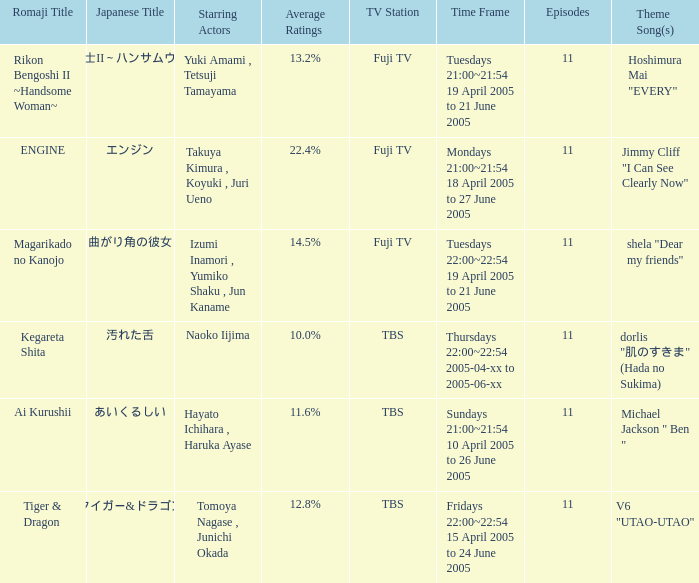What is the title with an average rating of 22.4%? ENGINE. 